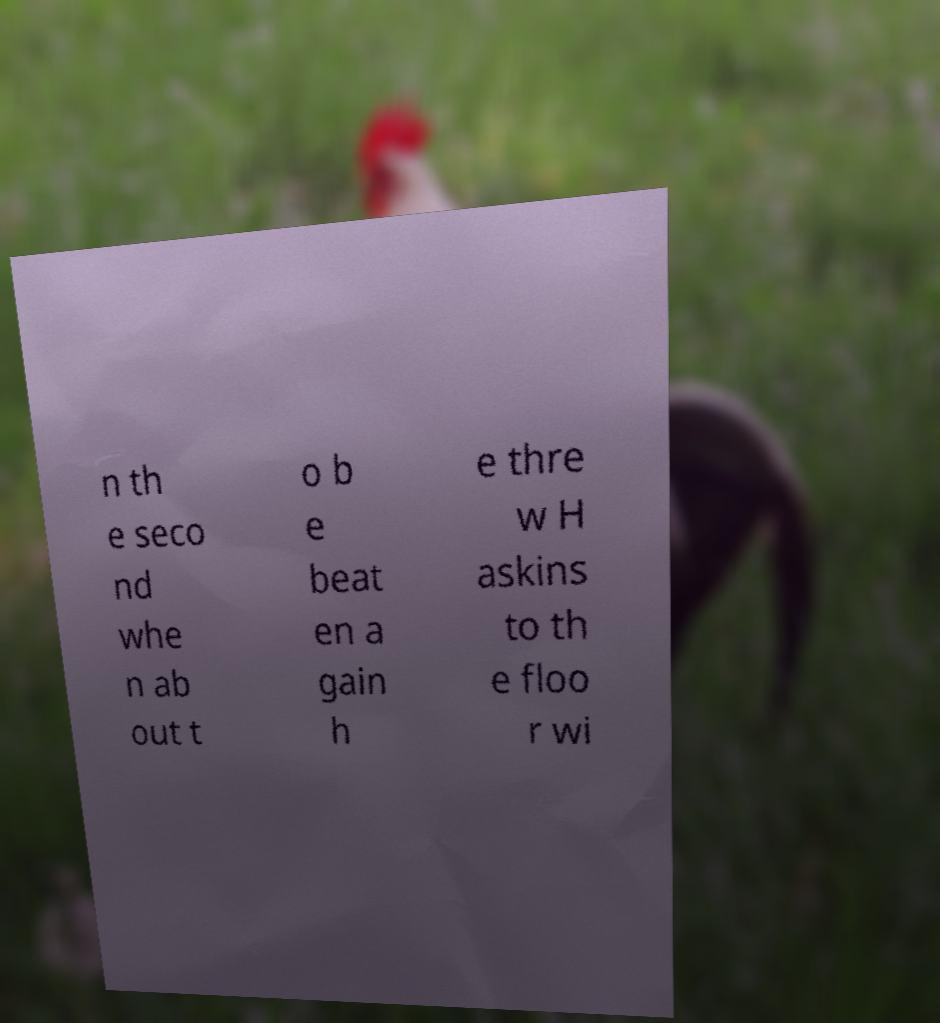For documentation purposes, I need the text within this image transcribed. Could you provide that? n th e seco nd whe n ab out t o b e beat en a gain h e thre w H askins to th e floo r wi 